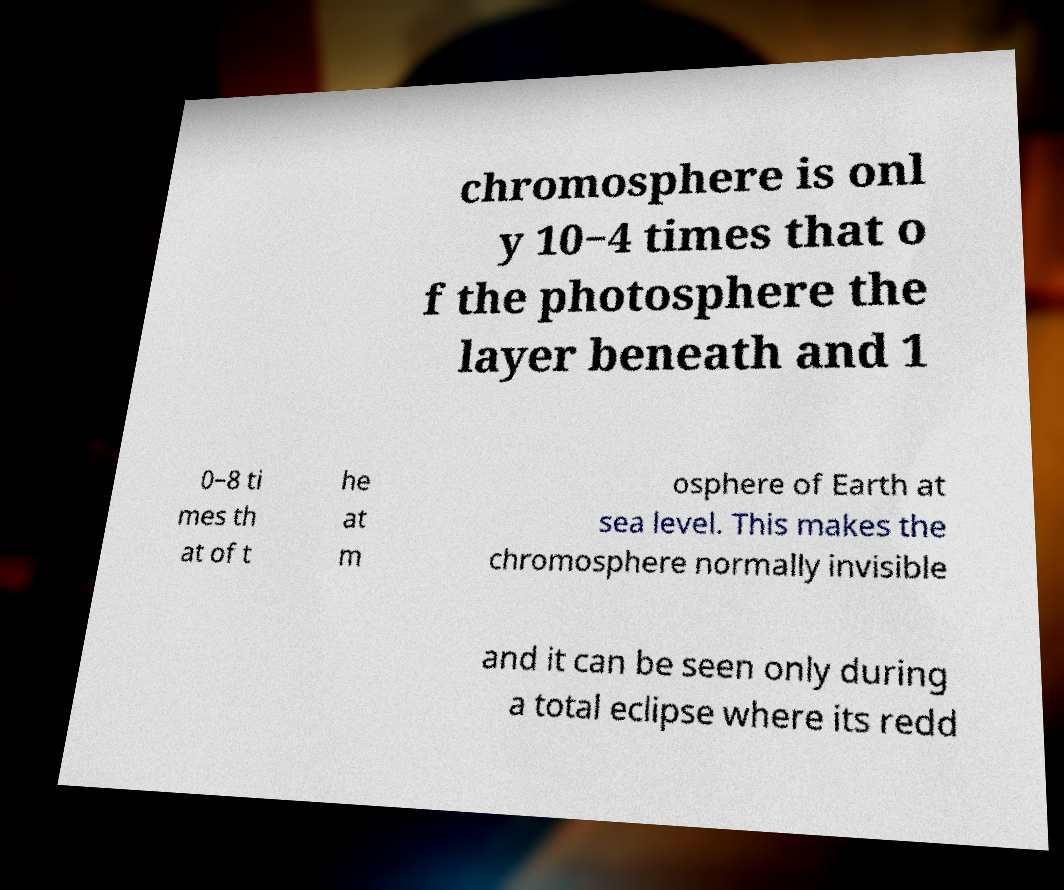Can you read and provide the text displayed in the image?This photo seems to have some interesting text. Can you extract and type it out for me? chromosphere is onl y 10−4 times that o f the photosphere the layer beneath and 1 0−8 ti mes th at of t he at m osphere of Earth at sea level. This makes the chromosphere normally invisible and it can be seen only during a total eclipse where its redd 